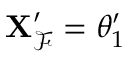Convert formula to latex. <formula><loc_0><loc_0><loc_500><loc_500>X _ { \mathcal { F } } ^ { \prime } = \theta _ { 1 } ^ { \prime }</formula> 